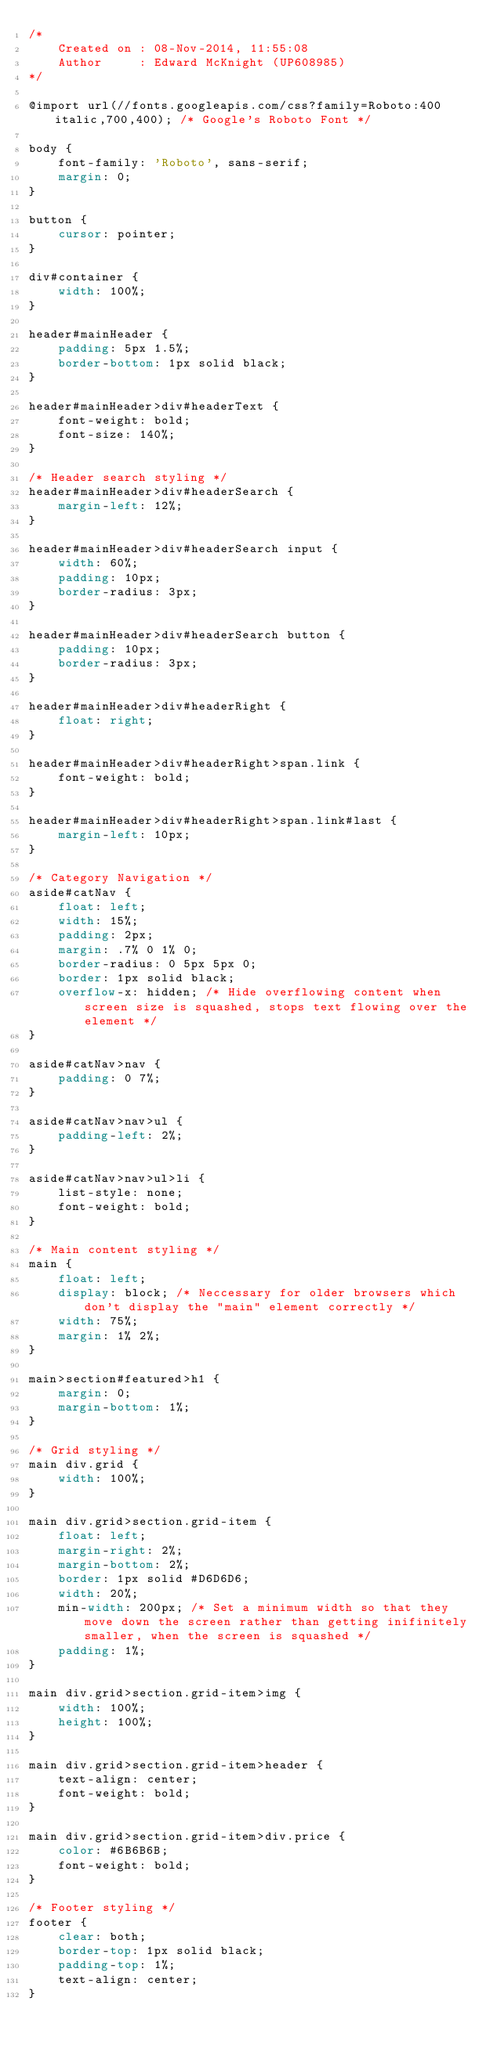<code> <loc_0><loc_0><loc_500><loc_500><_CSS_>/* 
    Created on : 08-Nov-2014, 11:55:08
    Author     : Edward McKnight (UP608985)
*/

@import url(//fonts.googleapis.com/css?family=Roboto:400italic,700,400); /* Google's Roboto Font */

body {
	font-family: 'Roboto', sans-serif;
	margin: 0;
}

button {
	cursor: pointer;
}

div#container {
	width: 100%;
}

header#mainHeader {
	padding: 5px 1.5%;
	border-bottom: 1px solid black;
}

header#mainHeader>div#headerText {
	font-weight: bold;
	font-size: 140%;
}

/* Header search styling */
header#mainHeader>div#headerSearch {
	margin-left: 12%;
}

header#mainHeader>div#headerSearch input {
	width: 60%;
	padding: 10px;
	border-radius: 3px;
}

header#mainHeader>div#headerSearch button {
	padding: 10px;
	border-radius: 3px;
}

header#mainHeader>div#headerRight {
	float: right;
}

header#mainHeader>div#headerRight>span.link {
	font-weight: bold;
}

header#mainHeader>div#headerRight>span.link#last {
	margin-left: 10px;
}

/* Category Navigation */
aside#catNav {
	float: left;
	width: 15%;
	padding: 2px;
	margin: .7% 0 1% 0;
	border-radius: 0 5px 5px 0;
	border: 1px solid black;
	overflow-x: hidden; /* Hide overflowing content when screen size is squashed, stops text flowing over the element */
}

aside#catNav>nav {
	padding: 0 7%;
}

aside#catNav>nav>ul {
	padding-left: 2%;
}

aside#catNav>nav>ul>li {
	list-style: none;
	font-weight: bold;
}

/* Main content styling */
main {
	float: left;
	display: block; /* Neccessary for older browsers which don't display the "main" element correctly */
	width: 75%;
	margin: 1% 2%;
}

main>section#featured>h1 {
	margin: 0;
	margin-bottom: 1%;
}

/* Grid styling */
main div.grid {
	width: 100%;
}

main div.grid>section.grid-item {
	float: left;
	margin-right: 2%;
	margin-bottom: 2%;
	border: 1px solid #D6D6D6;
	width: 20%;
	min-width: 200px; /* Set a minimum width so that they move down the screen rather than getting inifinitely smaller, when the screen is squashed */
	padding: 1%;
}

main div.grid>section.grid-item>img {
	width: 100%;
	height: 100%;
}

main div.grid>section.grid-item>header {
	text-align: center;
	font-weight: bold;
}

main div.grid>section.grid-item>div.price {
	color: #6B6B6B;
	font-weight: bold;
}

/* Footer styling */
footer {
	clear: both;
	border-top: 1px solid black;
	padding-top: 1%;
	text-align: center;
}</code> 